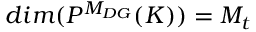<formula> <loc_0><loc_0><loc_500><loc_500>d i m ( P ^ { M _ { D G } } ( K ) ) = M _ { t }</formula> 